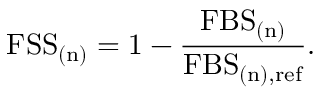Convert formula to latex. <formula><loc_0><loc_0><loc_500><loc_500>F S S _ { ( n ) } = 1 - \frac { F B S _ { ( n ) } } { F B S _ { ( n ) , r e f } } .</formula> 